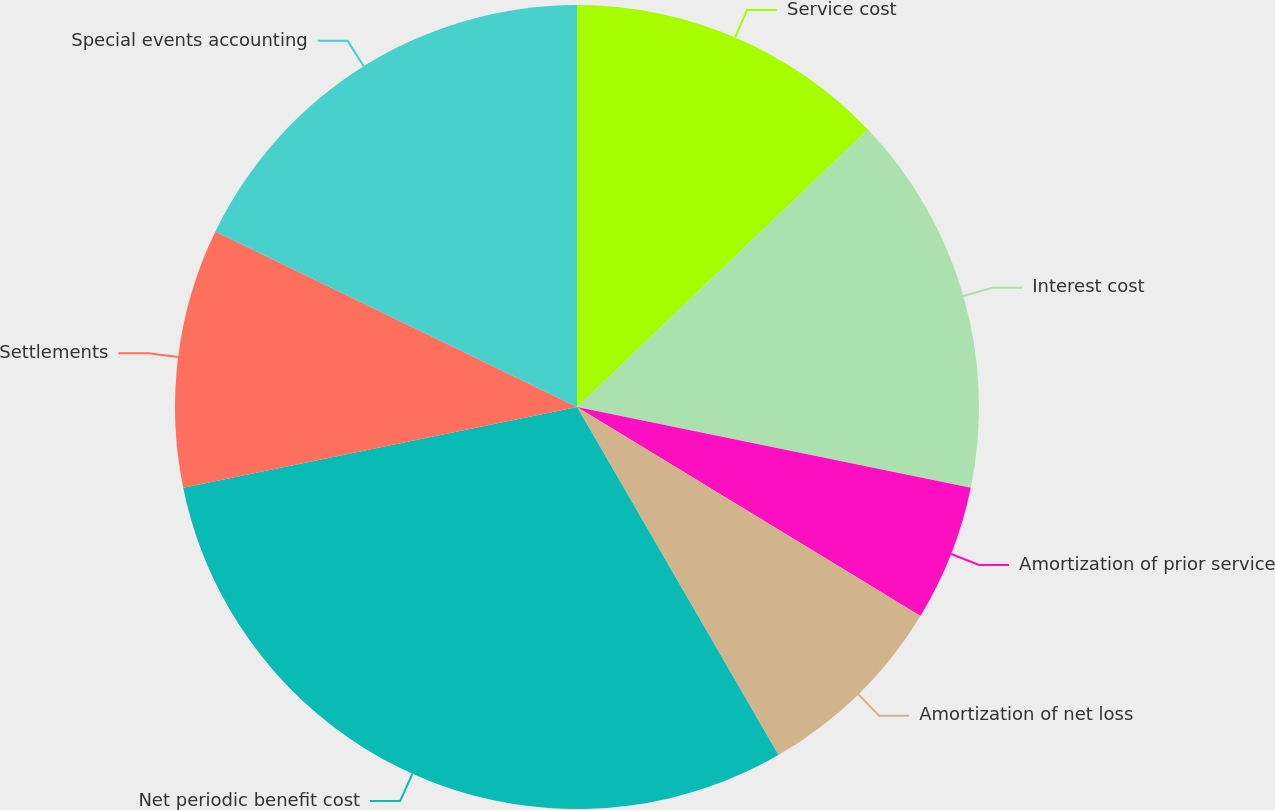Convert chart. <chart><loc_0><loc_0><loc_500><loc_500><pie_chart><fcel>Service cost<fcel>Interest cost<fcel>Amortization of prior service<fcel>Amortization of net loss<fcel>Net periodic benefit cost<fcel>Settlements<fcel>Special events accounting<nl><fcel>12.88%<fcel>15.34%<fcel>5.48%<fcel>7.95%<fcel>30.14%<fcel>10.41%<fcel>17.81%<nl></chart> 